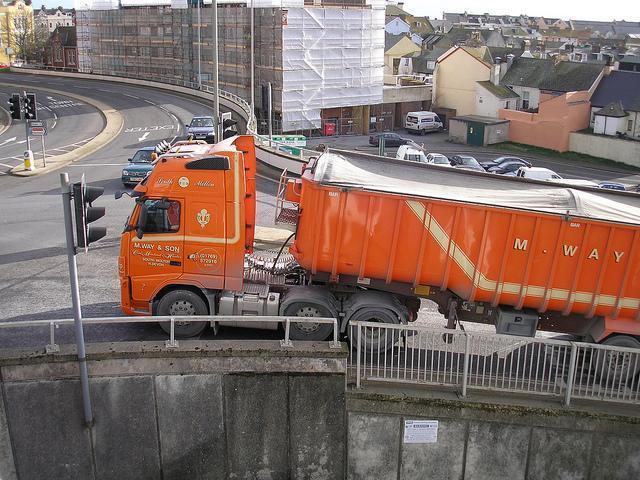How many trucks can be seen?
Give a very brief answer. 1. 